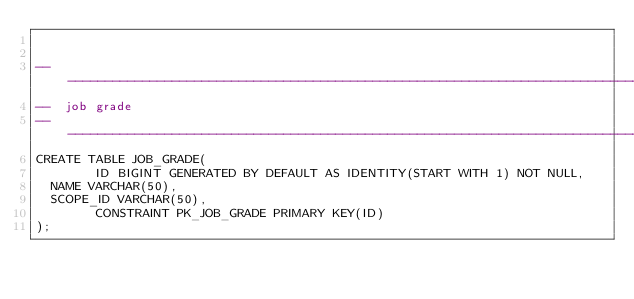<code> <loc_0><loc_0><loc_500><loc_500><_SQL_>

-------------------------------------------------------------------------------
--  job grade
-------------------------------------------------------------------------------
CREATE TABLE JOB_GRADE(
        ID BIGINT GENERATED BY DEFAULT AS IDENTITY(START WITH 1) NOT NULL,
	NAME VARCHAR(50),
	SCOPE_ID VARCHAR(50),
        CONSTRAINT PK_JOB_GRADE PRIMARY KEY(ID)
);

</code> 